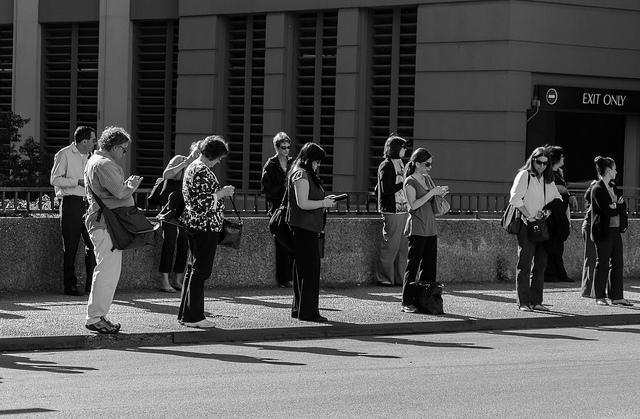How many people can you see?
Give a very brief answer. 11. How many light colored trucks are there?
Give a very brief answer. 0. 